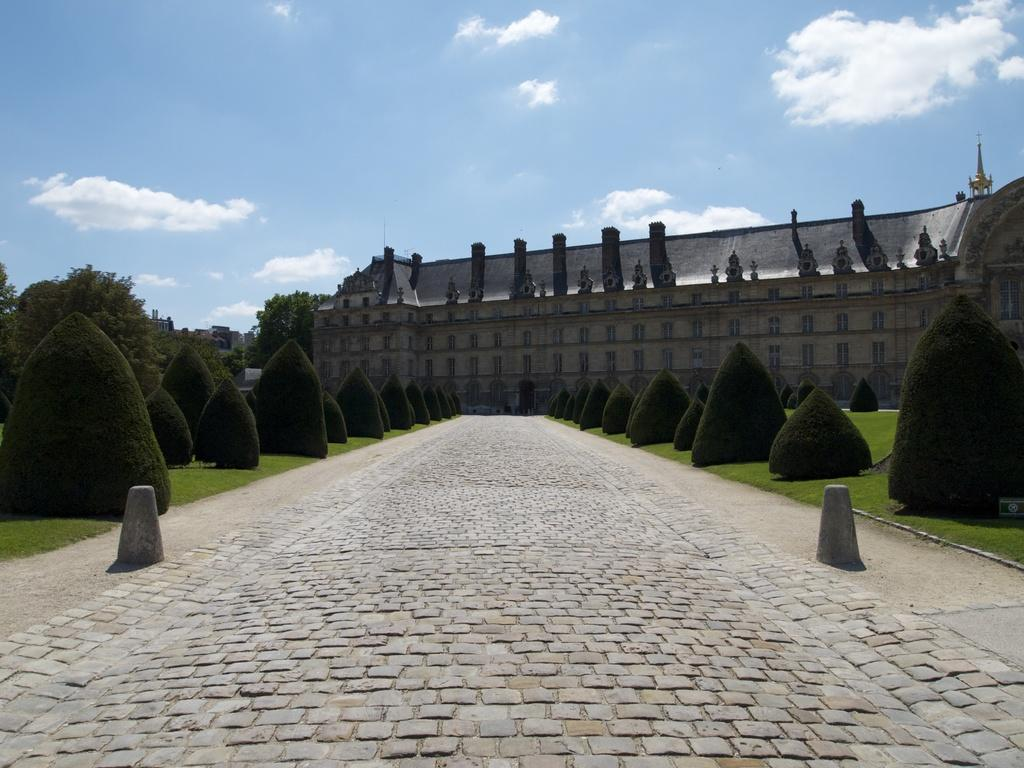What type of structure is visible in the image? There is a building in the image. What type of vegetation can be seen in the image? There are plants, grass, and trees in the image. What is the condition of the sky in the image? The sky is cloudy in the image. What type of bubble can be seen floating near the building in the image? There is no bubble present in the image. 